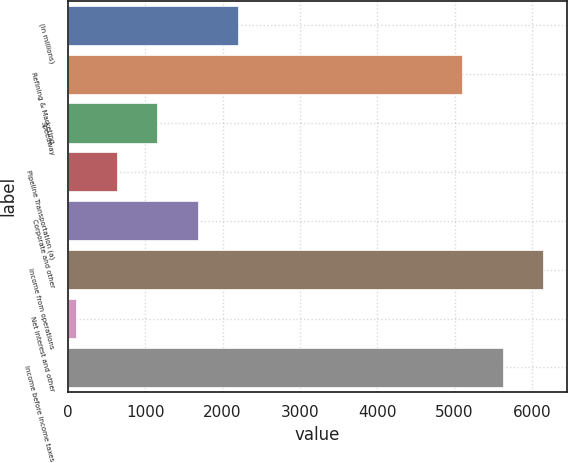<chart> <loc_0><loc_0><loc_500><loc_500><bar_chart><fcel>(In millions)<fcel>Refining & Marketing<fcel>Speedway<fcel>Pipeline Transportation (a)<fcel>Corporate and other<fcel>Income from operations<fcel>Net interest and other<fcel>Income before income taxes<nl><fcel>2204.2<fcel>5098<fcel>1156.6<fcel>632.8<fcel>1680.4<fcel>6145.6<fcel>109<fcel>5621.8<nl></chart> 